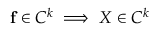<formula> <loc_0><loc_0><loc_500><loc_500>f \in C ^ { k } \implies X \in C ^ { k }</formula> 